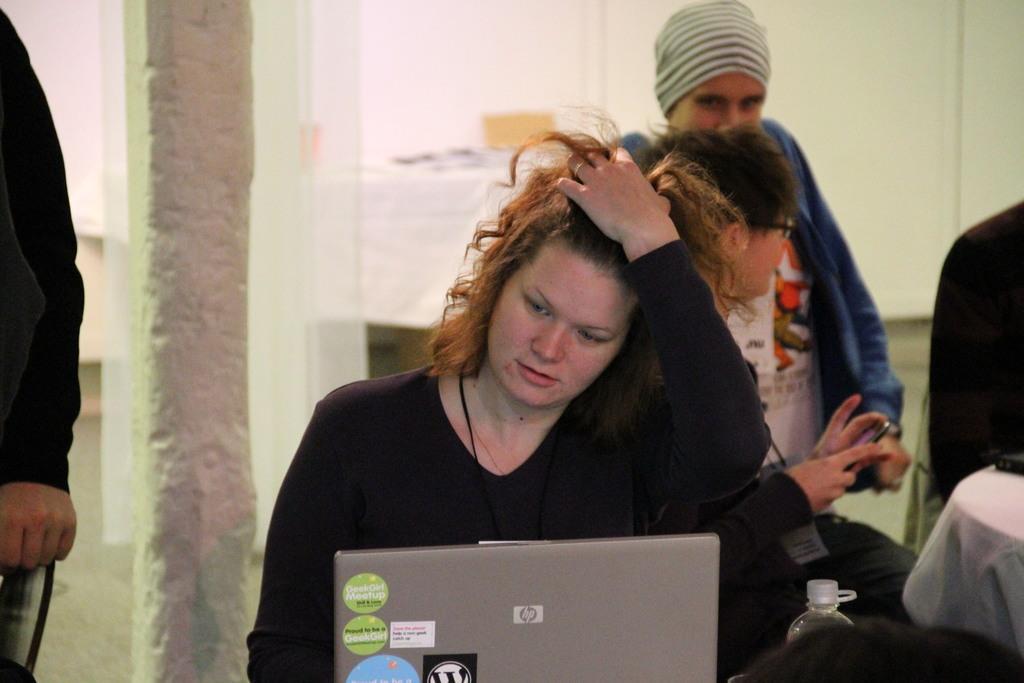How would you summarize this image in a sentence or two? In the foreground of the picture we can see a woman using laptop. In the middle there are two persons. On the left we can see a person. On the right there are table and other objects. In the background there are table, wall and other objects. 